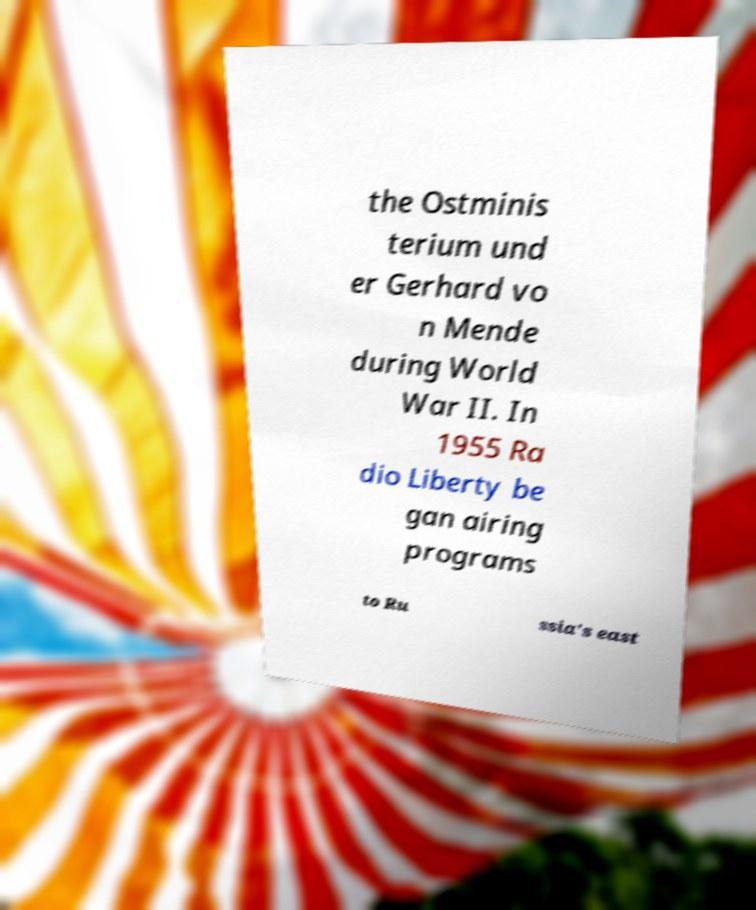What messages or text are displayed in this image? I need them in a readable, typed format. the Ostminis terium und er Gerhard vo n Mende during World War II. In 1955 Ra dio Liberty be gan airing programs to Ru ssia's east 